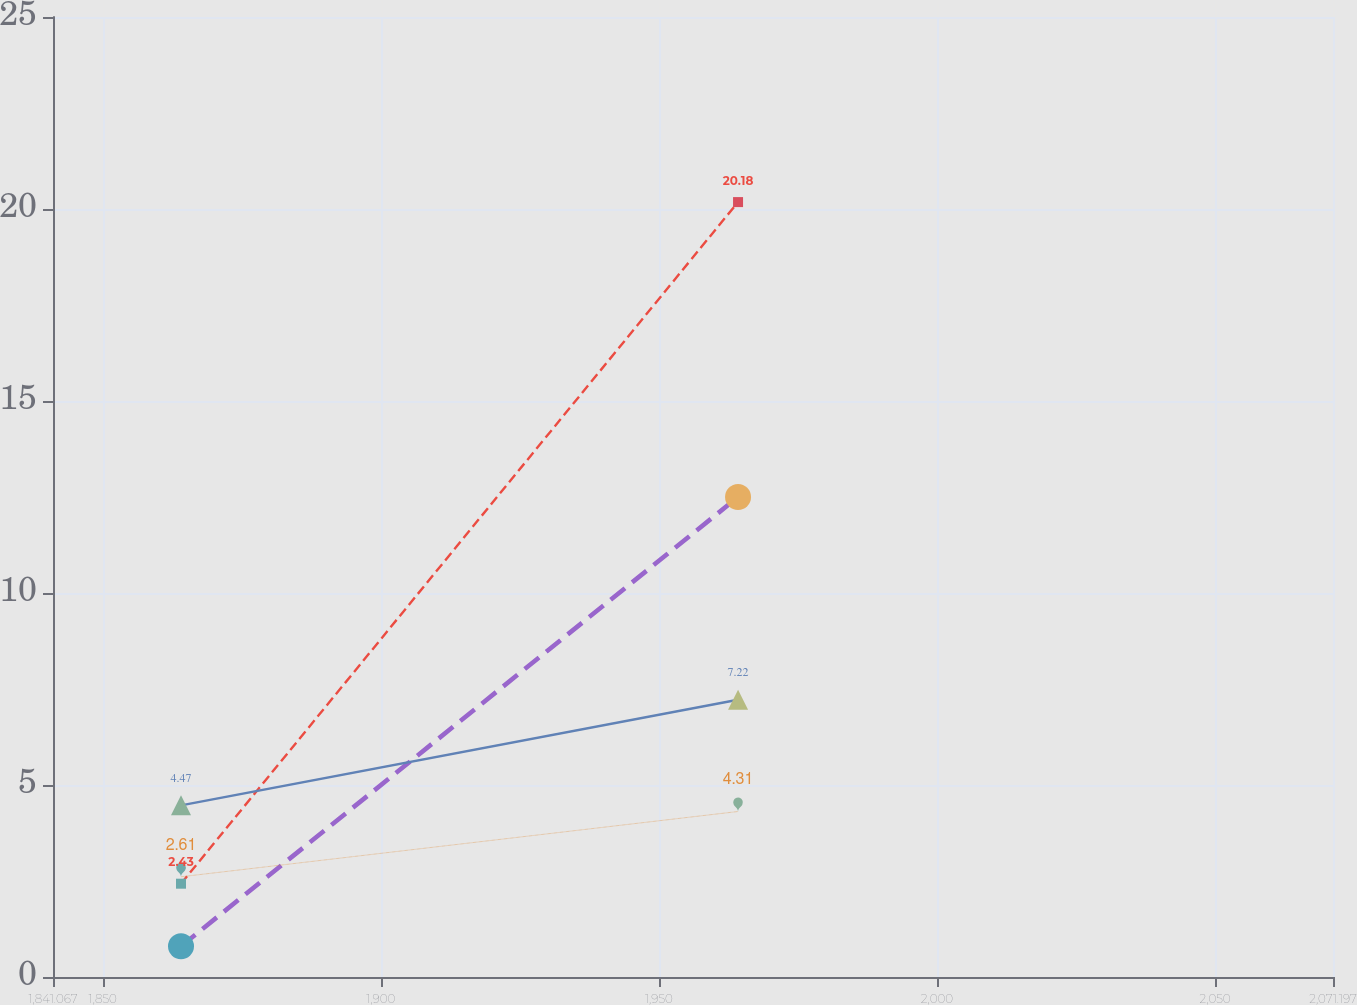<chart> <loc_0><loc_0><loc_500><loc_500><line_chart><ecel><fcel>Q3<fcel>Q1<fcel>Q2<fcel>Q4<nl><fcel>1864.08<fcel>2.43<fcel>0.8<fcel>4.47<fcel>2.61<nl><fcel>1964.23<fcel>20.18<fcel>12.5<fcel>7.22<fcel>4.31<nl><fcel>2094.21<fcel>18.47<fcel>13.74<fcel>13.74<fcel>19.66<nl></chart> 